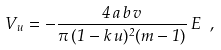Convert formula to latex. <formula><loc_0><loc_0><loc_500><loc_500>V _ { u } = - \frac { 4 \, a \, b \, v } { \pi \, ( 1 - k \, u ) ^ { 2 } ( m - 1 ) } \, E \ ,</formula> 